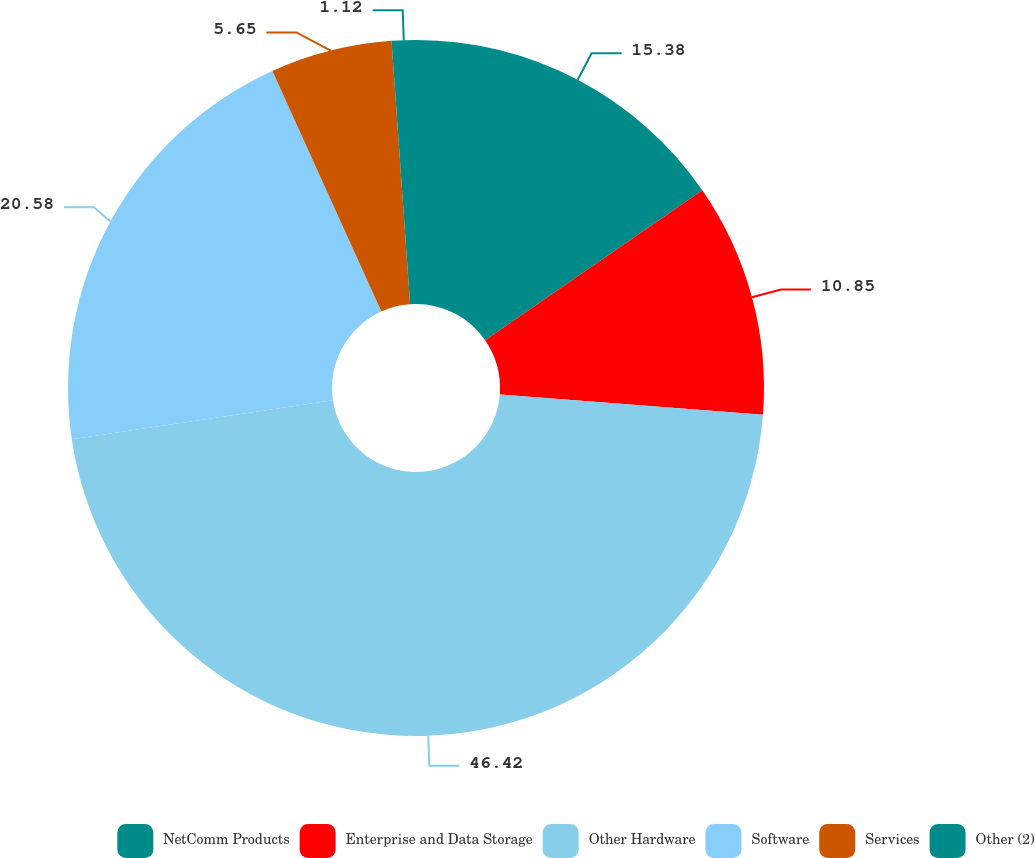<chart> <loc_0><loc_0><loc_500><loc_500><pie_chart><fcel>NetComm Products<fcel>Enterprise and Data Storage<fcel>Other Hardware<fcel>Software<fcel>Services<fcel>Other (2)<nl><fcel>15.38%<fcel>10.85%<fcel>46.42%<fcel>20.58%<fcel>5.65%<fcel>1.12%<nl></chart> 